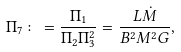<formula> <loc_0><loc_0><loc_500><loc_500>\Pi _ { 7 } \colon = \frac { \Pi _ { 1 } } { \Pi _ { 2 } \Pi _ { 3 } ^ { 2 } } = \frac { L \dot { M } } { B ^ { 2 } M ^ { 2 } G } ,</formula> 